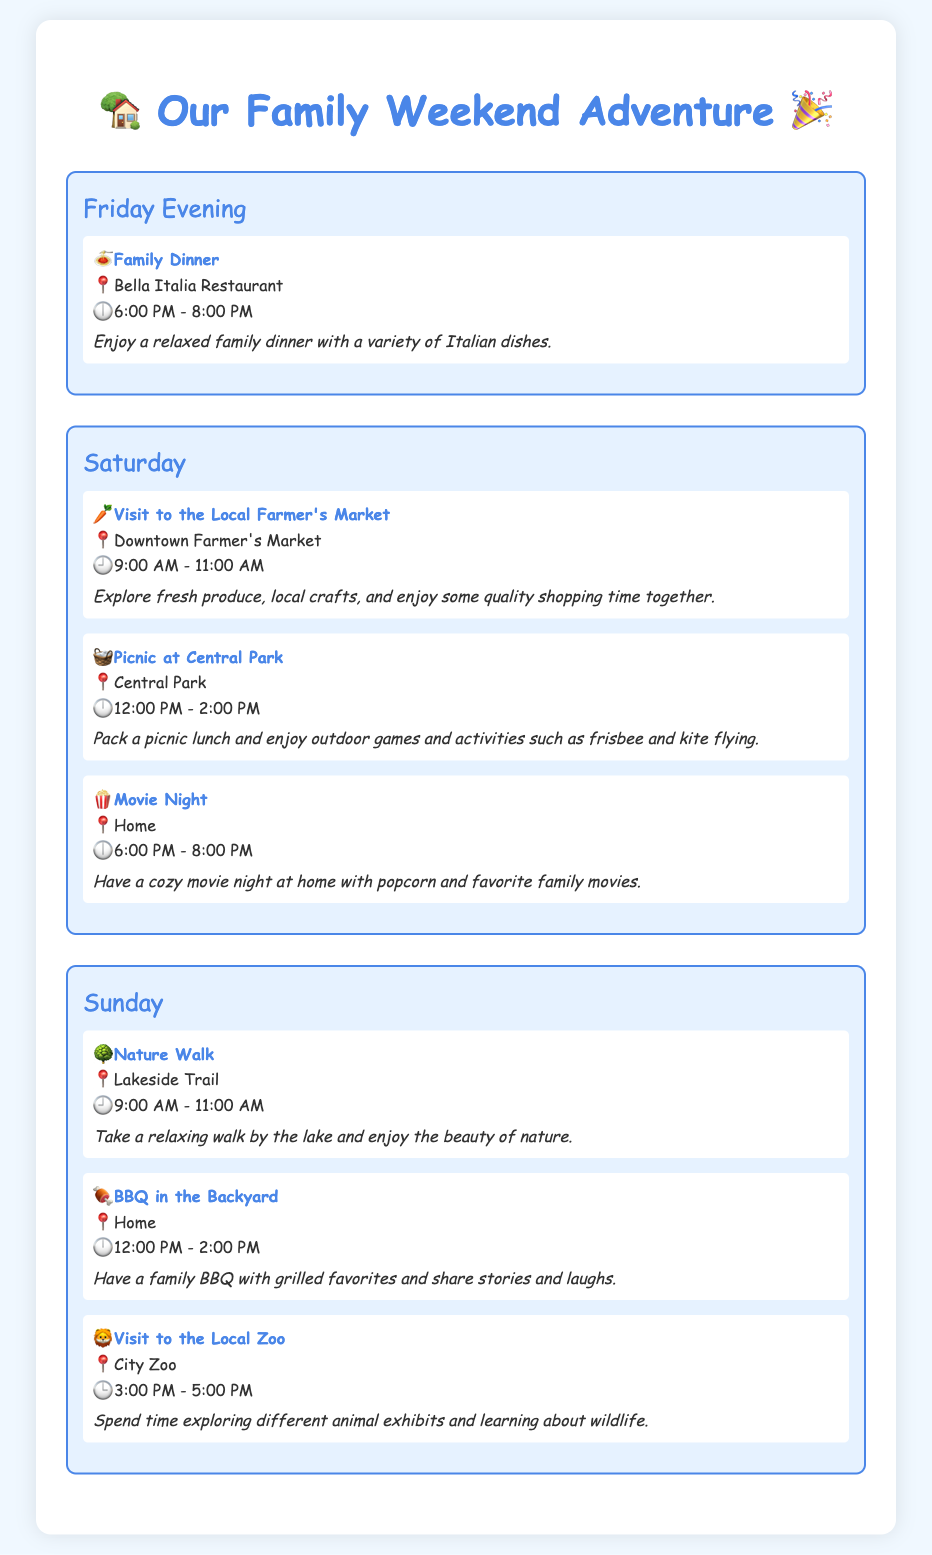What time does the family dinner start? The family dinner is scheduled to start at 6:00 PM on Friday evening.
Answer: 6:00 PM Where is the picnic taking place? The picnic is set to happen at Central Park as indicated in the itinerary.
Answer: Central Park What activity is planned at 12:00 PM on Sunday? At 12:00 PM on Sunday, there is a family BBQ planned.
Answer: BBQ in the Backyard How long is the visit to the local farmer's market? The visit to the local farmer's market lasts for 2 hours, from 9:00 AM to 11:00 AM.
Answer: 2 hours What type of food is enjoyed during the family dinner? The family dinner features a variety of Italian dishes as mentioned in the document.
Answer: Italian dishes What is scheduled after the nature walk on Sunday? After the nature walk, the family has a BBQ planned in the backyard according to the order of activities.
Answer: BBQ in the Backyard How many activities are planned for Saturday? There are three activities scheduled for Saturday, as outlined in the itinerary.
Answer: Three activities What is the main focus of the visit to the local zoo? The focus of the visit to the local zoo is exploring animal exhibits and learning about wildlife.
Answer: Exploring animal exhibits What icon represents the family dinner? The family dinner is represented by a pasta icon (🍝) in the itinerary.
Answer: 🍝 